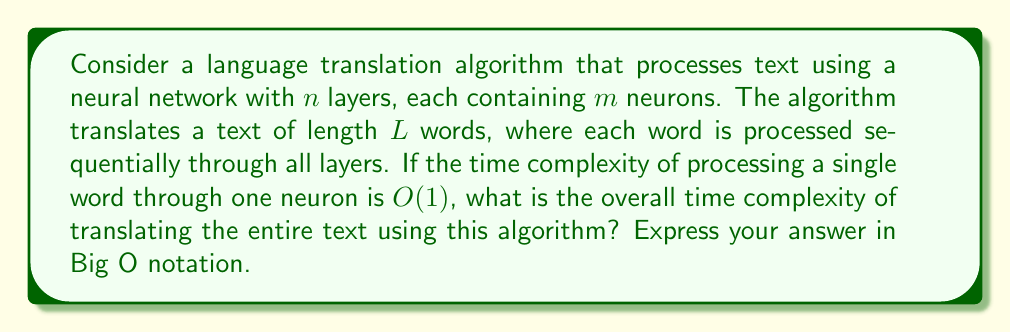Help me with this question. To solve this problem, we need to break it down into steps and analyze the time complexity of each component:

1. Text length: The text has $L$ words.

2. Neural network structure:
   - $n$ layers
   - $m$ neurons per layer

3. Processing a single word:
   - Each word goes through all $n$ layers
   - In each layer, it is processed by all $m$ neurons
   - Processing through one neuron takes $O(1)$ time

Let's calculate the time complexity:

a) For a single word:
   - Time per layer = $O(m)$ (processed by $m$ neurons)
   - Time for all layers = $O(nm)$ (processed through $n$ layers)

b) For the entire text:
   - Total time = Time per word × Number of words
   - Total time = $O(nm) \times L$

Therefore, the overall time complexity is:

$$O(nmL)$$

This complexity reflects the linear scaling with respect to the text length ($L$), the number of layers ($n$), and the number of neurons per layer ($m$).

For a prolific author whose works undergo linguistic transformations, this complexity is particularly relevant. As the author's vocabulary and style evolve over time, the translation algorithm may need to process increasingly complex linguistic structures, potentially requiring more sophisticated neural network architectures (larger $n$ and $m$) to capture these nuances accurately.
Answer: $O(nmL)$ 